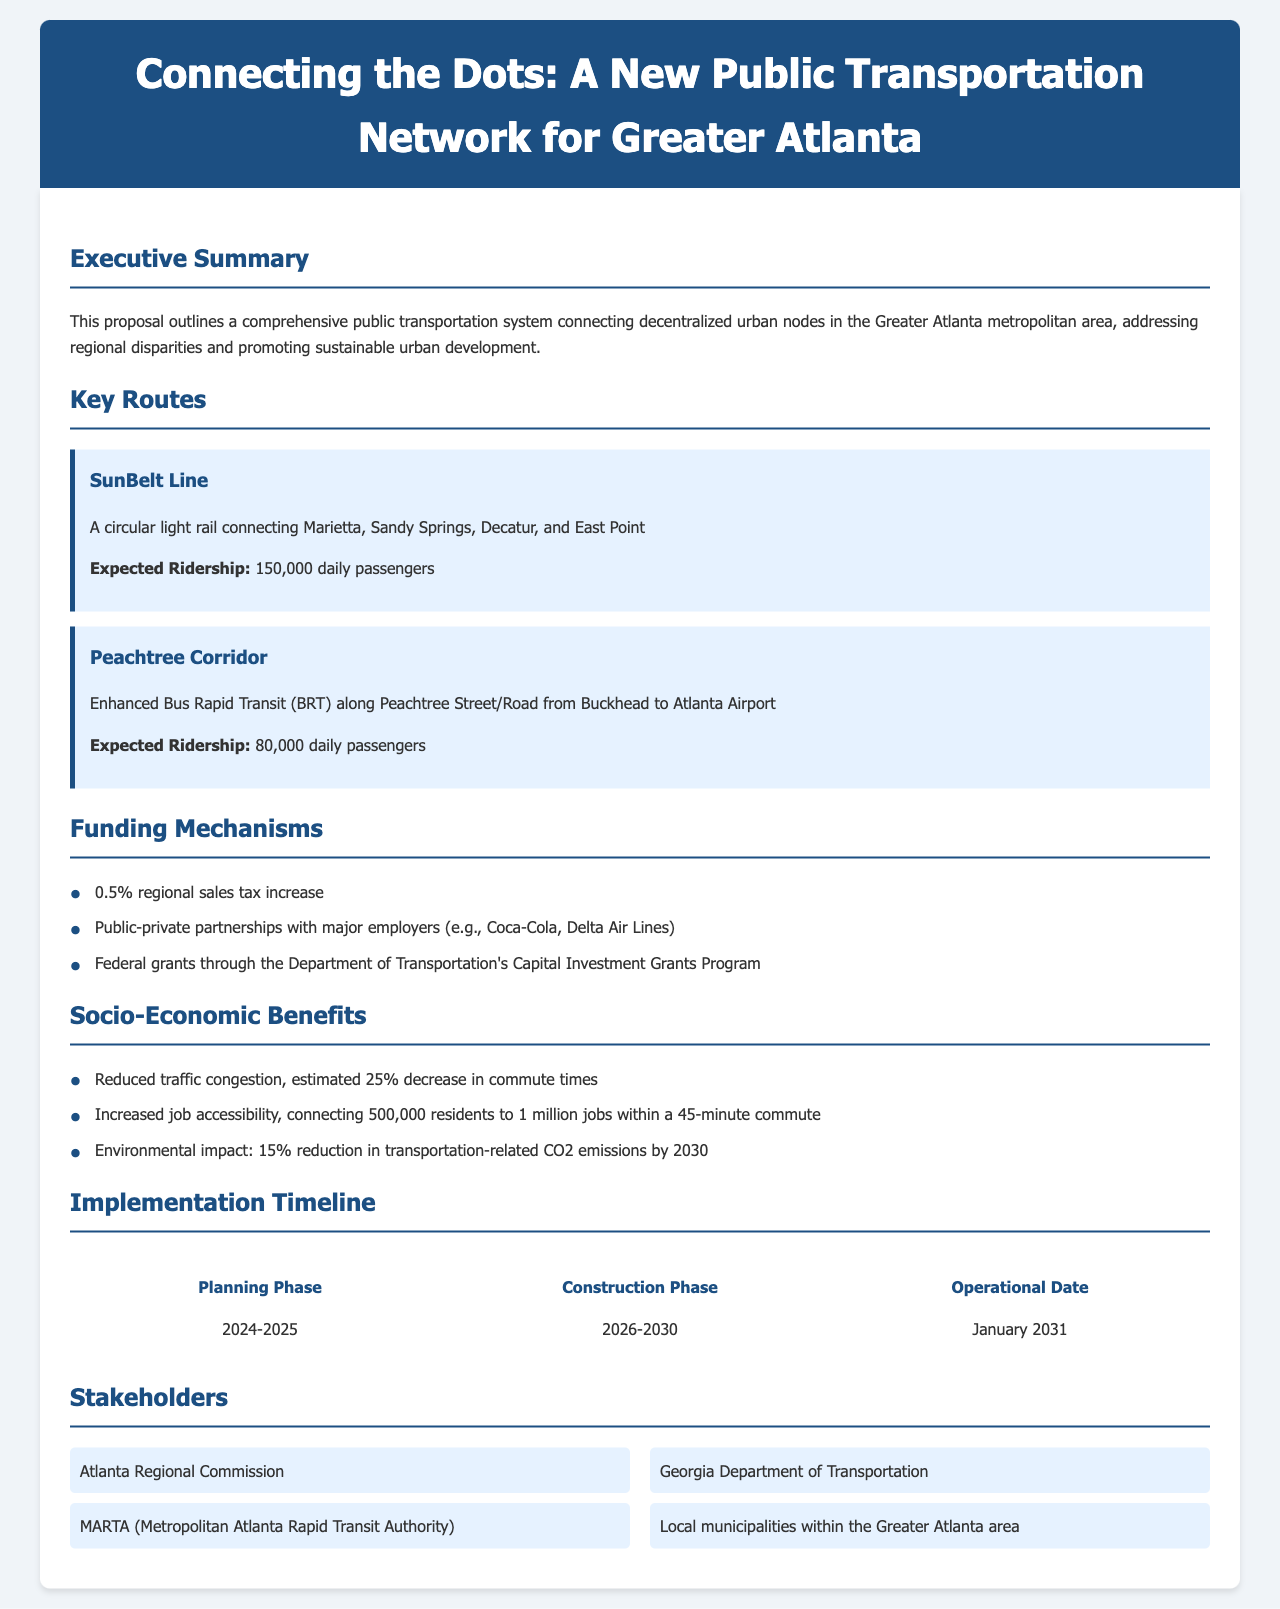What is the title of the proposal? The title of the proposal is the heading at the top of the document, which outlines the subject matter.
Answer: Connecting the Dots: A New Public Transportation Network for Greater Atlanta What is the expected ridership for the SunBelt Line? The expected ridership is mentioned explicitly in the section detailing routes, specifically for the SunBelt Line.
Answer: 150,000 daily passengers What percentage will the regional sales tax increase? The proposal specifies the increase in regional sales tax under the funding mechanisms, providing a clear number.
Answer: 0.5% What is the operational date for the new transportation system? The operational date is listed in the implementation timeline section of the document.
Answer: January 2031 How much will commute times decrease as a result of the new system? The expected impact on commute times is quantified within the socio-economic benefits section.
Answer: 25% What entities are listed as stakeholders in the proposal? Stakeholders include various organizations and departments mentioned in the stakeholders section, showcasing who is involved.
Answer: Atlanta Regional Commission, Georgia Department of Transportation, MARTA, Local municipalities What is the construction phase duration? The timeframe for the construction phase is given in the implementation timeline, indicating when it will occur.
Answer: 2026-2030 How many jobs are accessible within a 45-minute commute? The document specifies how many jobs will be made more accessible by this transportation system under socio-economic benefits.
Answer: 1 million jobs 